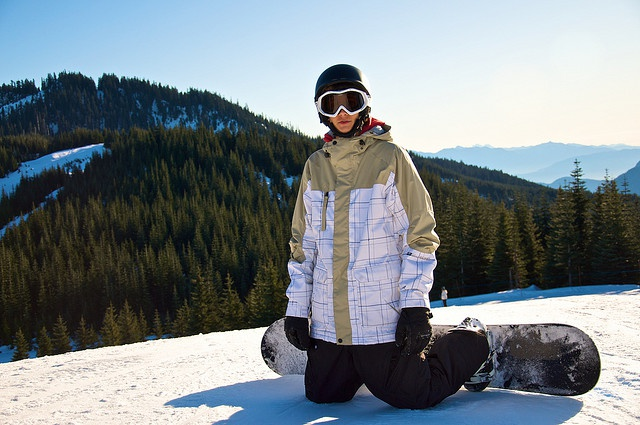Describe the objects in this image and their specific colors. I can see people in lightblue, black, darkgray, and gray tones and snowboard in lightblue, black, gray, and darkgray tones in this image. 